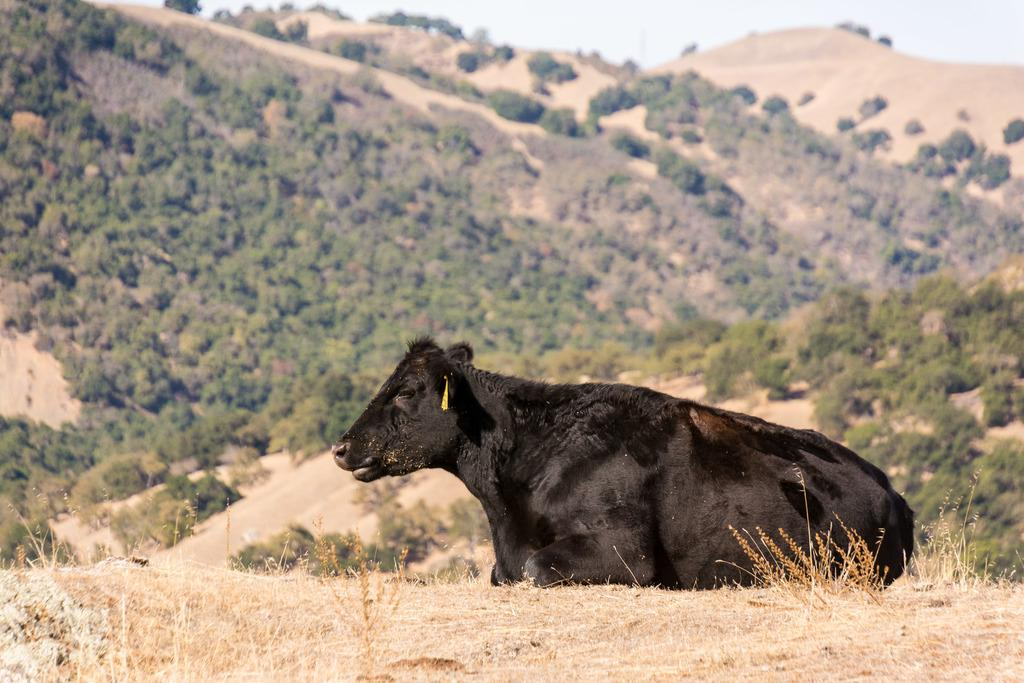What animal is sitting on the grass in the image? There is a cow sitting on the grass in the image. What type of landscape can be seen in the background of the image? There are mountains covered with trees in the image. What type of vegetation is visible in the image? There are trees visible in the image. What is visible above the landscape in the image? The sky is visible in the image. What type of berry is the cow eating in the image? There is no berry present in the image, and the cow is not shown eating anything. 